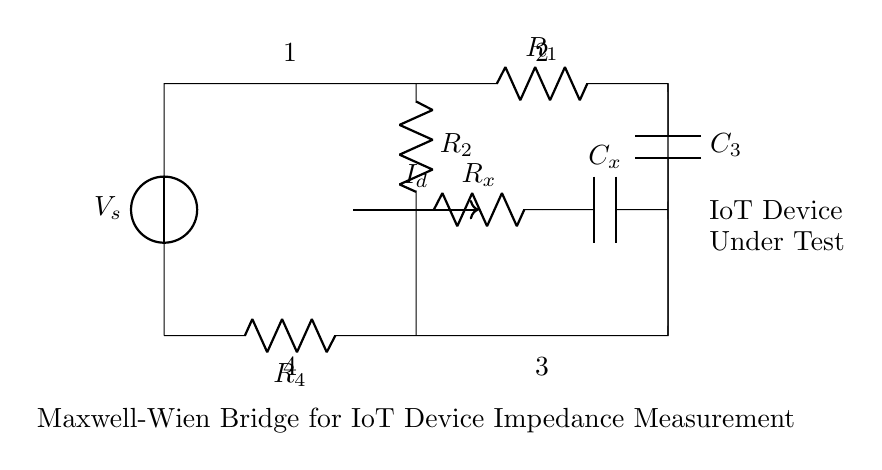What is the voltage source labeled in the circuit? The voltage source is labeled as V_s, indicating the power supply for the circuit.
Answer: V_s What is the impedance being measured represented as? The impedance being measured is represented as R_x in the circuit diagram.
Answer: R_x How many resistors are in the circuit? There are a total of four resistors in the circuit, which are labeled R_1, R_2, R_4, and R_x.
Answer: 4 What is the purpose of the capacitors in the circuit? The capacitors, particularly C_3 and C_x, are included in the bridge to measure complex impedance, consisting of both resistive and reactive components.
Answer: Measure complex impedance Which two points are connected by the current labeled I_d? The current I_d flows through the branch between R_2 and R_x, signifying a measurement point or balance condition in the Maxwell-Wien bridge.
Answer: Between R_2 and R_x What is the role of the Maxwell-Wien bridge in this circuit? The Maxwell-Wien bridge is designed specifically for accurately measuring the impedance of the IoT device connected in the circuit, which is important for ensuring proper function in web-connected applications.
Answer: Impedance measurement What is the labeling of the IoT device in the circuit? The IoT device under test is labeled as "IoT Device" and "Under Test," indicating the component whose impedance is being evaluated and measured by the bridge.
Answer: IoT Device 